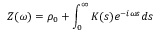<formula> <loc_0><loc_0><loc_500><loc_500>Z ( \omega ) = \rho _ { 0 } + \int _ { 0 } ^ { \infty } K ( s ) e ^ { - i \omega s } d s</formula> 